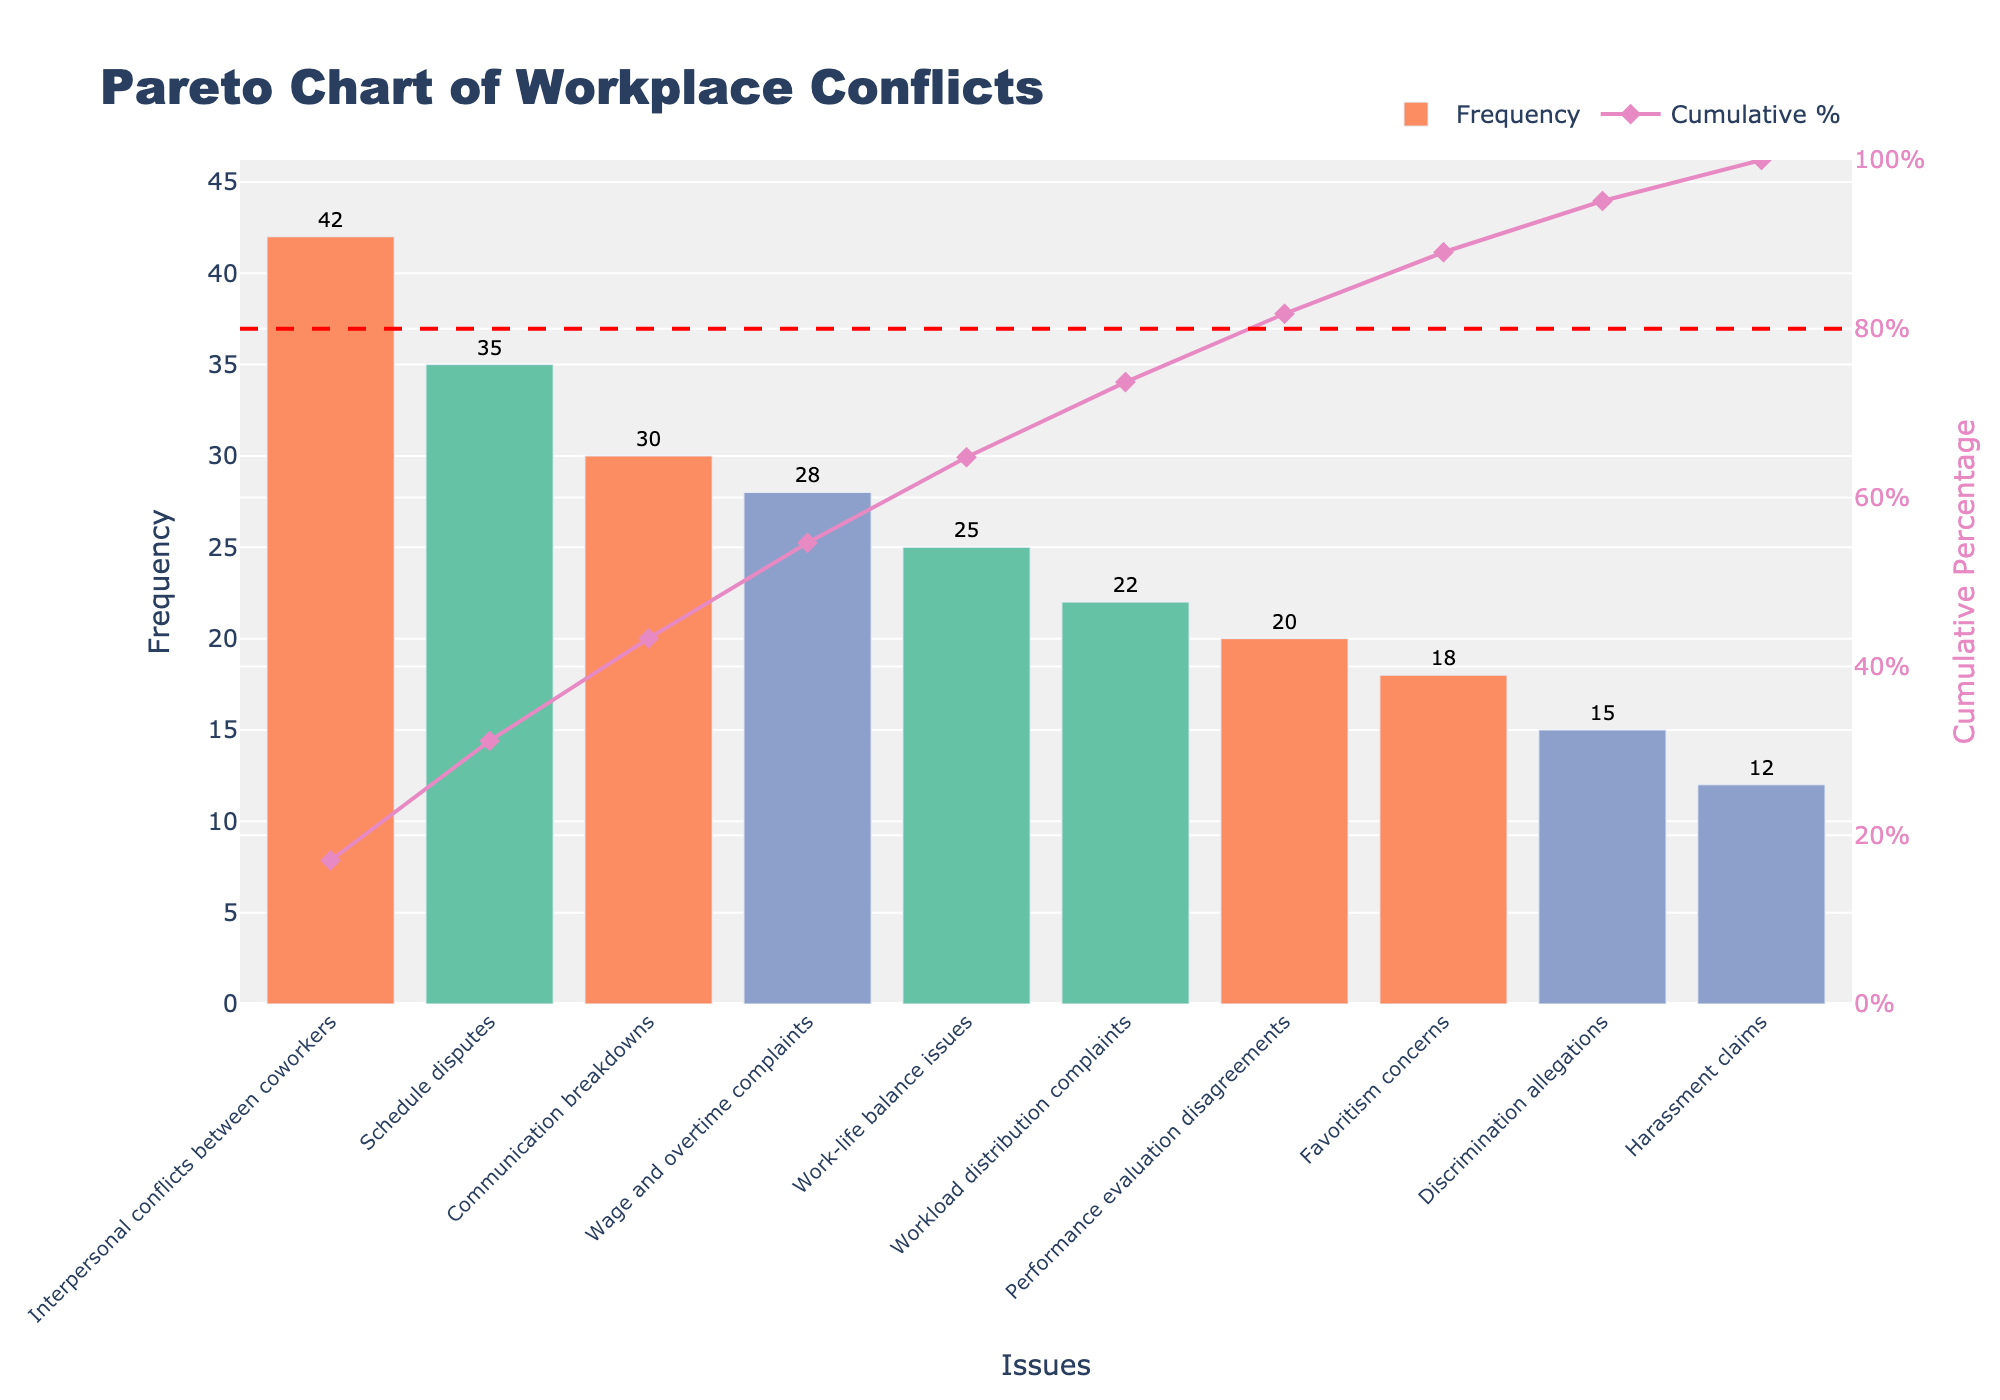What's the title of the chart? The title of the chart is displayed at the top of the figure.
Answer: Pareto Chart of Workplace Conflicts How many issues are listed in the chart? Count the number of unique issue labels on the x-axis.
Answer: 10 Which issue has the highest frequency? Refer to the bar with the maximum height on the left side of the chart.
Answer: Interpersonal conflicts between coworkers What color represents the 'High' severity category? Identify the color of the bars with 'High' severity; the color key helps with this.
Answer: A shade of blue (violet-like) What's the cumulative percentage after the top three most frequent issues? Look at the cumulative percentage line (diamond markers) after the third issue and read the corresponding value on the right y-axis.
Answer: 53.0% Which issue has a 'Low' severity but is higher than a 'Medium' severity issue in frequency? Identify the issues with 'Low' severity and compare their frequencies with issues of 'Medium' severity. 'Schedule disputes' is low and has a frequency higher than 'Performance evaluation disagreements,' which is medium.
Answer: Schedule disputes Arrange the issues with 'High' severity in descending order by frequency. List the issues labeled as 'High' severity and sort them by the height of their respective bars from highest to lowest.
Answer: Wage and overtime complaints, Discrimination allegations, Harassment claims What is the cumulative percentage at the 80% reference line? Identify the intersection of the cumulative percentage line with the 80% horizontal reference line and find the corresponding issue. Read the cumulative percentage value from the right y-axis.
Answer: 80% Which issue's frequency causes the cumulative percentage to first surpass 50%? Follow the cumulative percentage line up to where it first crosses 50% and identify the corresponding issue.
Answer: Communication breakdowns 